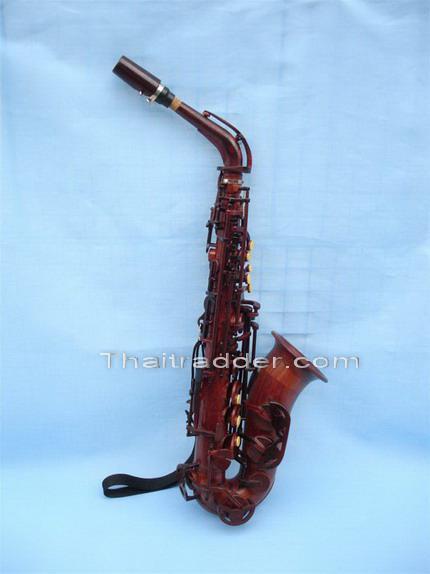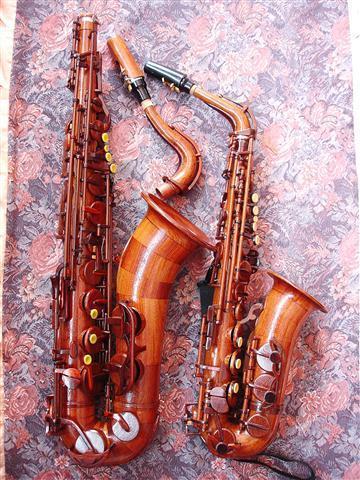The first image is the image on the left, the second image is the image on the right. Given the left and right images, does the statement "One image contains three or more saxophones." hold true? Answer yes or no. No. 